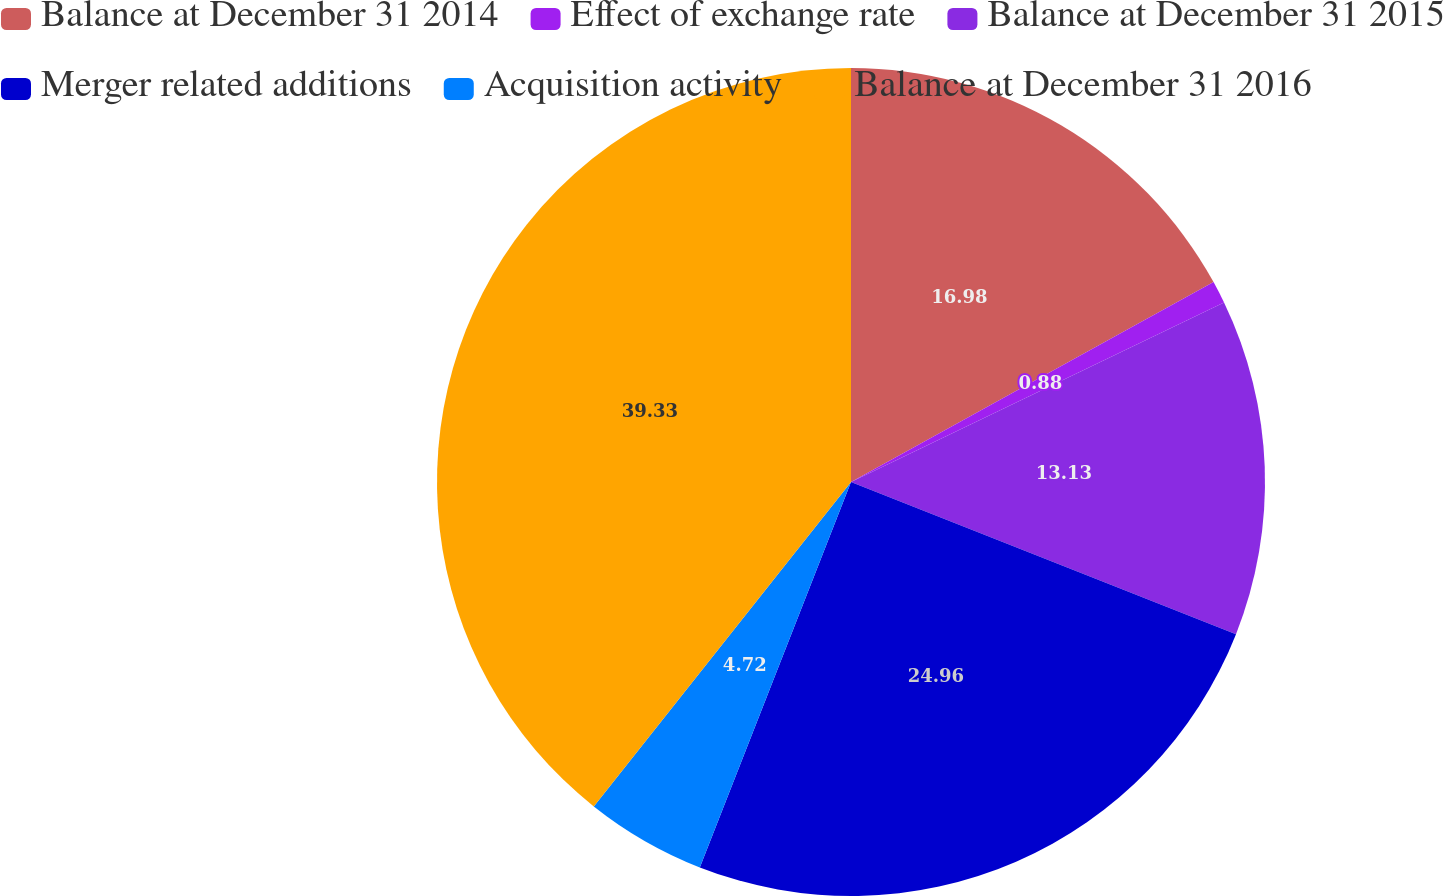Convert chart to OTSL. <chart><loc_0><loc_0><loc_500><loc_500><pie_chart><fcel>Balance at December 31 2014<fcel>Effect of exchange rate<fcel>Balance at December 31 2015<fcel>Merger related additions<fcel>Acquisition activity<fcel>Balance at December 31 2016<nl><fcel>16.98%<fcel>0.88%<fcel>13.13%<fcel>24.96%<fcel>4.72%<fcel>39.33%<nl></chart> 